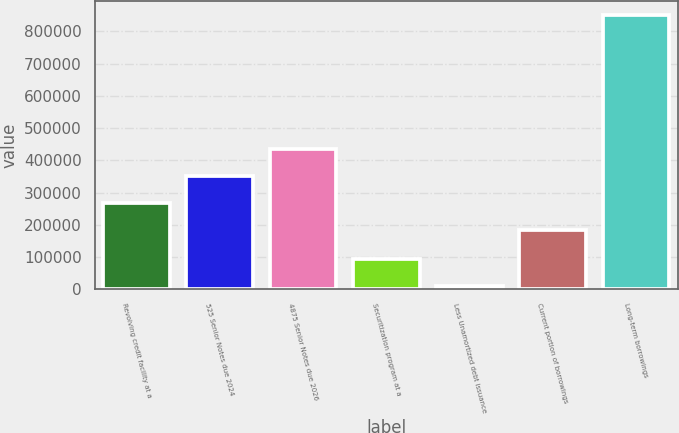Convert chart. <chart><loc_0><loc_0><loc_500><loc_500><bar_chart><fcel>Revolving credit facility at a<fcel>525 Senior Notes due 2024<fcel>4875 Senior Notes due 2026<fcel>Securitization program at a<fcel>Less Unamortized debt issuance<fcel>Current portion of borrowings<fcel>Long-term borrowings<nl><fcel>267092<fcel>351112<fcel>435133<fcel>94066.6<fcel>10046<fcel>183071<fcel>850252<nl></chart> 